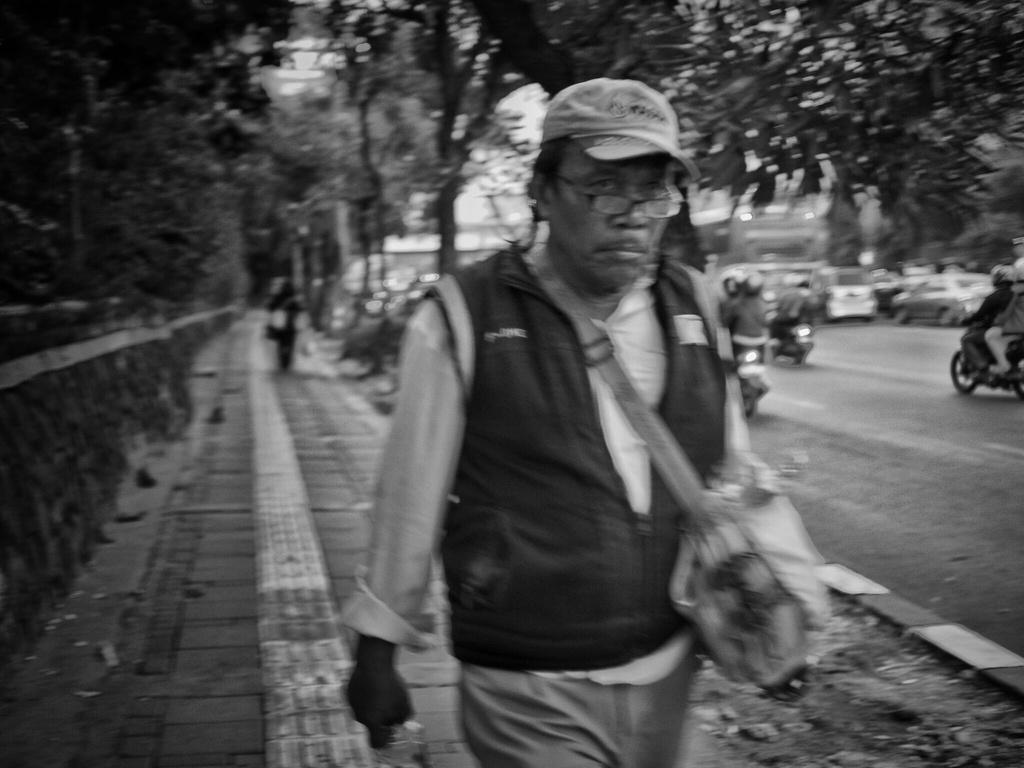What is the color scheme of the image? The image is black and white. Who or what can be seen in the image? There are people and vehicles in the image. What type of natural elements are present in the image? There are trees in the image. What is the surface on which the people and vehicles are situated? The ground is visible in the image. Where are the objects located in the image? The objects are on the left side of the image. What nation is attempting to wire the objects in the image? There is no mention of a nation or an attempt to wire any objects in the image. The image only shows people, vehicles, trees, and objects in black and white. 